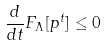Convert formula to latex. <formula><loc_0><loc_0><loc_500><loc_500>\frac { d } { d t } F _ { \Lambda } [ p ^ { t } ] \leq 0</formula> 